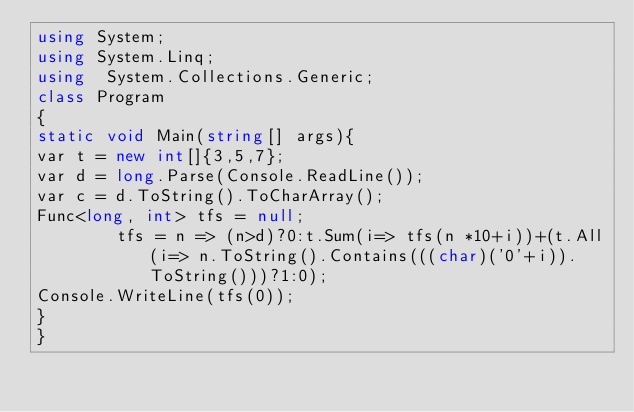Convert code to text. <code><loc_0><loc_0><loc_500><loc_500><_C#_>using System;
using System.Linq;
using  System.Collections.Generic;
class Program
{
static void Main(string[] args){
var t = new int[]{3,5,7};
var d = long.Parse(Console.ReadLine());
var c = d.ToString().ToCharArray();
Func<long, int> tfs = null;
        tfs = n => (n>d)?0:t.Sum(i=> tfs(n *10+i))+(t.All(i=> n.ToString().Contains(((char)('0'+i)).ToString()))?1:0);
Console.WriteLine(tfs(0));
}
}</code> 